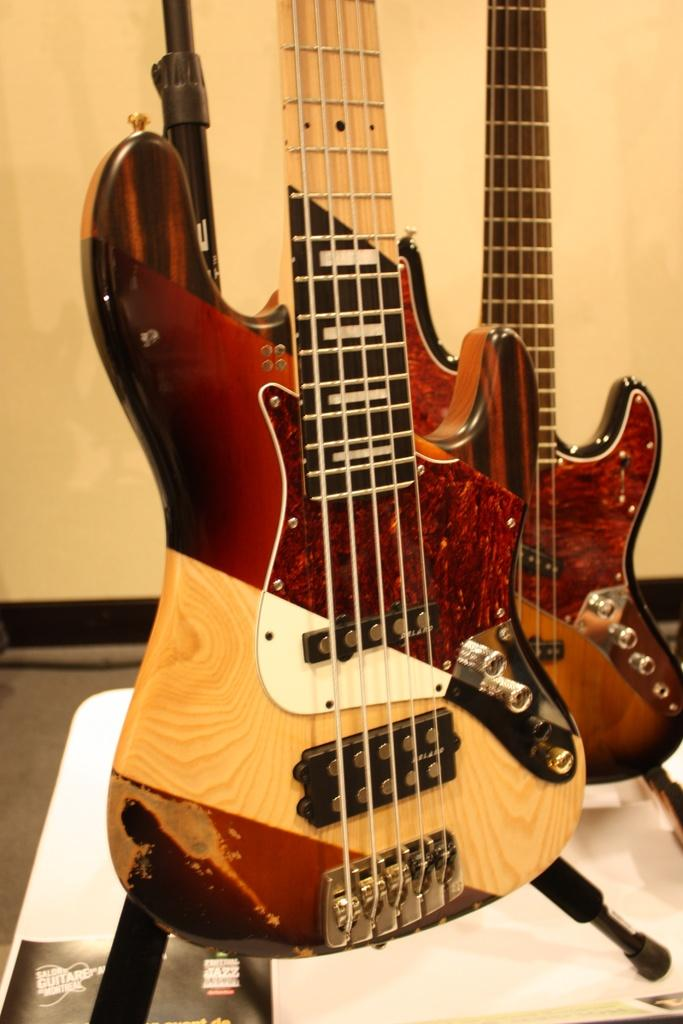What musical instruments are present in the image? There are two guitars in the image. Where are the guitars placed? The guitars are placed on a white table. What is on the table besides the guitars? There is a black color paper on the table. What can be seen in the background of the image? The background of the image includes a plain wall. What type of polish is being applied to the guitars in the image? There is no indication in the image that any polish is being applied to the guitars. 